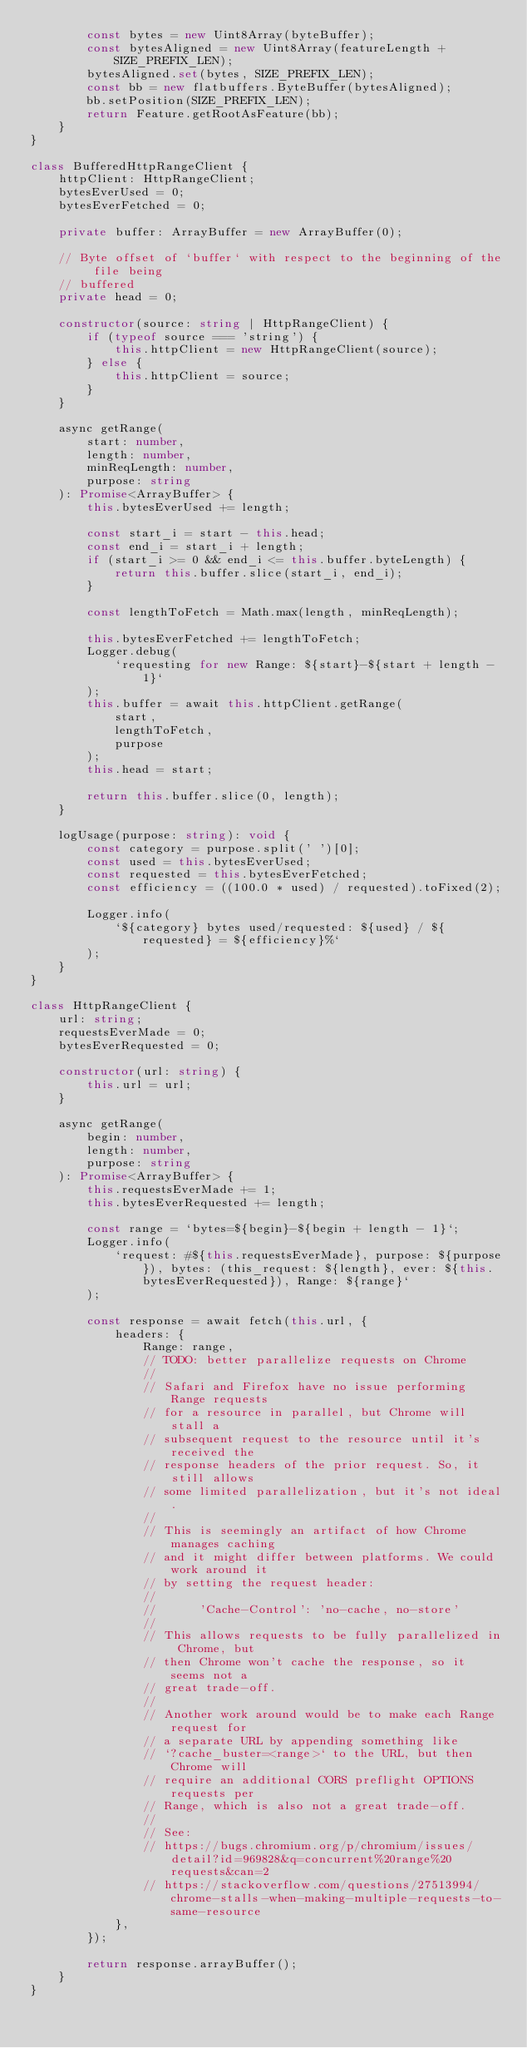<code> <loc_0><loc_0><loc_500><loc_500><_TypeScript_>        const bytes = new Uint8Array(byteBuffer);
        const bytesAligned = new Uint8Array(featureLength + SIZE_PREFIX_LEN);
        bytesAligned.set(bytes, SIZE_PREFIX_LEN);
        const bb = new flatbuffers.ByteBuffer(bytesAligned);
        bb.setPosition(SIZE_PREFIX_LEN);
        return Feature.getRootAsFeature(bb);
    }
}

class BufferedHttpRangeClient {
    httpClient: HttpRangeClient;
    bytesEverUsed = 0;
    bytesEverFetched = 0;

    private buffer: ArrayBuffer = new ArrayBuffer(0);

    // Byte offset of `buffer` with respect to the beginning of the file being
    // buffered
    private head = 0;

    constructor(source: string | HttpRangeClient) {
        if (typeof source === 'string') {
            this.httpClient = new HttpRangeClient(source);
        } else {
            this.httpClient = source;
        }
    }

    async getRange(
        start: number,
        length: number,
        minReqLength: number,
        purpose: string
    ): Promise<ArrayBuffer> {
        this.bytesEverUsed += length;

        const start_i = start - this.head;
        const end_i = start_i + length;
        if (start_i >= 0 && end_i <= this.buffer.byteLength) {
            return this.buffer.slice(start_i, end_i);
        }

        const lengthToFetch = Math.max(length, minReqLength);

        this.bytesEverFetched += lengthToFetch;
        Logger.debug(
            `requesting for new Range: ${start}-${start + length - 1}`
        );
        this.buffer = await this.httpClient.getRange(
            start,
            lengthToFetch,
            purpose
        );
        this.head = start;

        return this.buffer.slice(0, length);
    }

    logUsage(purpose: string): void {
        const category = purpose.split(' ')[0];
        const used = this.bytesEverUsed;
        const requested = this.bytesEverFetched;
        const efficiency = ((100.0 * used) / requested).toFixed(2);

        Logger.info(
            `${category} bytes used/requested: ${used} / ${requested} = ${efficiency}%`
        );
    }
}

class HttpRangeClient {
    url: string;
    requestsEverMade = 0;
    bytesEverRequested = 0;

    constructor(url: string) {
        this.url = url;
    }

    async getRange(
        begin: number,
        length: number,
        purpose: string
    ): Promise<ArrayBuffer> {
        this.requestsEverMade += 1;
        this.bytesEverRequested += length;

        const range = `bytes=${begin}-${begin + length - 1}`;
        Logger.info(
            `request: #${this.requestsEverMade}, purpose: ${purpose}), bytes: (this_request: ${length}, ever: ${this.bytesEverRequested}), Range: ${range}`
        );

        const response = await fetch(this.url, {
            headers: {
                Range: range,
                // TODO: better parallelize requests on Chrome
                //
                // Safari and Firefox have no issue performing Range requests
                // for a resource in parallel, but Chrome will stall a
                // subsequent request to the resource until it's received the
                // response headers of the prior request. So, it still allows
                // some limited parallelization, but it's not ideal.
                //
                // This is seemingly an artifact of how Chrome manages caching
                // and it might differ between platforms. We could work around it
                // by setting the request header:
                //
                //      'Cache-Control': 'no-cache, no-store'
                //
                // This allows requests to be fully parallelized in Chrome, but
                // then Chrome won't cache the response, so it seems not a
                // great trade-off.
                //
                // Another work around would be to make each Range request for
                // a separate URL by appending something like
                // `?cache_buster=<range>` to the URL, but then Chrome will
                // require an additional CORS preflight OPTIONS requests per
                // Range, which is also not a great trade-off.
                //
                // See:
                // https://bugs.chromium.org/p/chromium/issues/detail?id=969828&q=concurrent%20range%20requests&can=2
                // https://stackoverflow.com/questions/27513994/chrome-stalls-when-making-multiple-requests-to-same-resource
            },
        });

        return response.arrayBuffer();
    }
}
</code> 